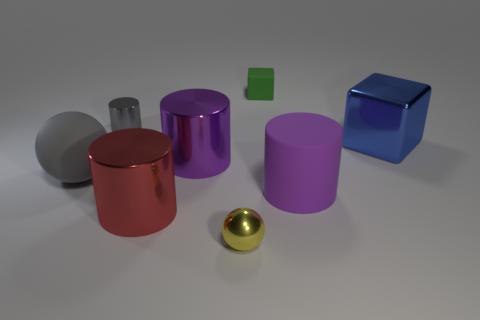Add 1 tiny gray things. How many objects exist? 9 Subtract all spheres. How many objects are left? 6 Add 6 large blue rubber cylinders. How many large blue rubber cylinders exist? 6 Subtract 0 brown cylinders. How many objects are left? 8 Subtract all tiny purple cylinders. Subtract all gray cylinders. How many objects are left? 7 Add 7 yellow metallic balls. How many yellow metallic balls are left? 8 